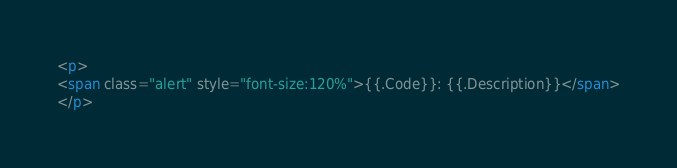<code> <loc_0><loc_0><loc_500><loc_500><_HTML_><p>
<span class="alert" style="font-size:120%">{{.Code}}: {{.Description}}</span>
</p>
</code> 